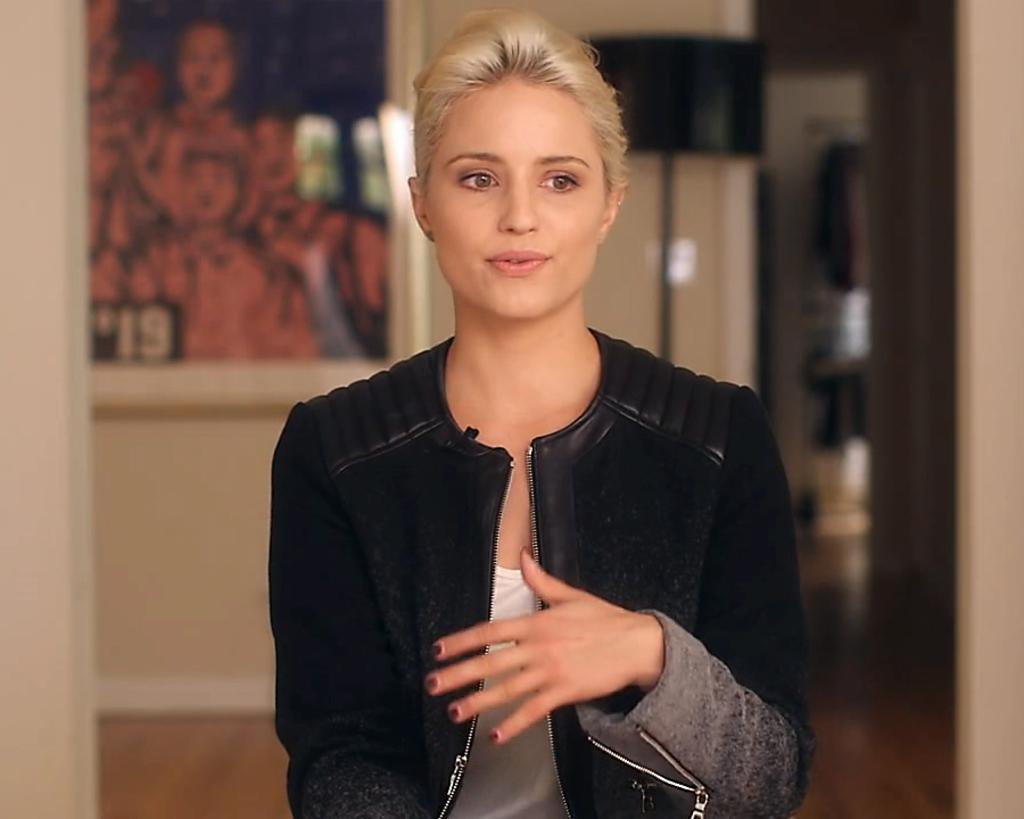Who is the main subject in the image? There is a woman in the image. What is the woman wearing? The woman is wearing clothes. What objects can be seen in the image besides the woman? There is a lamp and a frame in the image. What type of surface is visible in the image? There is a floor in the image. What type of foot is visible in the image? There is no foot visible in the image; it only shows a woman, a lamp, a frame, and a floor. 